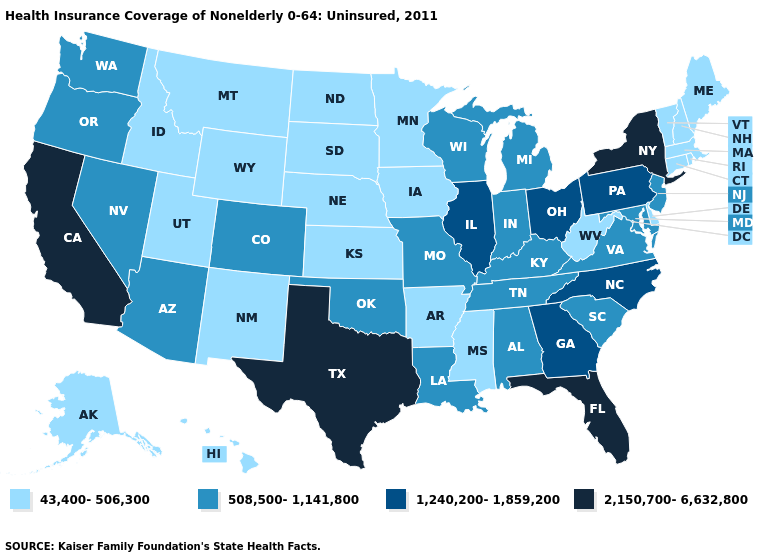What is the highest value in the USA?
Keep it brief. 2,150,700-6,632,800. Does Rhode Island have a lower value than Massachusetts?
Short answer required. No. What is the value of Nebraska?
Answer briefly. 43,400-506,300. Which states have the lowest value in the USA?
Short answer required. Alaska, Arkansas, Connecticut, Delaware, Hawaii, Idaho, Iowa, Kansas, Maine, Massachusetts, Minnesota, Mississippi, Montana, Nebraska, New Hampshire, New Mexico, North Dakota, Rhode Island, South Dakota, Utah, Vermont, West Virginia, Wyoming. Name the states that have a value in the range 508,500-1,141,800?
Give a very brief answer. Alabama, Arizona, Colorado, Indiana, Kentucky, Louisiana, Maryland, Michigan, Missouri, Nevada, New Jersey, Oklahoma, Oregon, South Carolina, Tennessee, Virginia, Washington, Wisconsin. Does Oregon have a higher value than Arkansas?
Give a very brief answer. Yes. Does Rhode Island have the highest value in the Northeast?
Keep it brief. No. Does Virginia have the lowest value in the USA?
Concise answer only. No. Which states have the lowest value in the USA?
Give a very brief answer. Alaska, Arkansas, Connecticut, Delaware, Hawaii, Idaho, Iowa, Kansas, Maine, Massachusetts, Minnesota, Mississippi, Montana, Nebraska, New Hampshire, New Mexico, North Dakota, Rhode Island, South Dakota, Utah, Vermont, West Virginia, Wyoming. Does Indiana have the lowest value in the MidWest?
Be succinct. No. What is the lowest value in states that border New York?
Quick response, please. 43,400-506,300. What is the lowest value in states that border Colorado?
Concise answer only. 43,400-506,300. Name the states that have a value in the range 43,400-506,300?
Concise answer only. Alaska, Arkansas, Connecticut, Delaware, Hawaii, Idaho, Iowa, Kansas, Maine, Massachusetts, Minnesota, Mississippi, Montana, Nebraska, New Hampshire, New Mexico, North Dakota, Rhode Island, South Dakota, Utah, Vermont, West Virginia, Wyoming. Name the states that have a value in the range 1,240,200-1,859,200?
Concise answer only. Georgia, Illinois, North Carolina, Ohio, Pennsylvania. What is the value of Wisconsin?
Answer briefly. 508,500-1,141,800. 